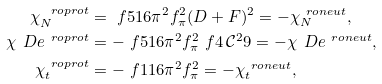Convert formula to latex. <formula><loc_0><loc_0><loc_500><loc_500>\chi _ { N } ^ { \ r o { p r o t } } & = \ f { 5 } { 1 6 \pi ^ { 2 } f _ { \pi } ^ { 2 } } ( D + F ) ^ { 2 } = - \chi _ { N } ^ { \ r o { n e u t } } , \\ \chi _ { \ } D e ^ { \ r o { p r o t } } & = - \ f { 5 } { 1 6 \pi ^ { 2 } f _ { \pi } ^ { 2 } } \ f { 4 \, \mathcal { C } ^ { 2 } } { 9 } = - \chi _ { \ } D e ^ { \ r o { n e u t } } , \\ \chi _ { t } ^ { \ r o { p r o t } } & = - \ f { 1 } { 1 6 \pi ^ { 2 } f _ { \pi } ^ { 2 } } = - \chi _ { t } ^ { \ r o { n e u t } } ,</formula> 